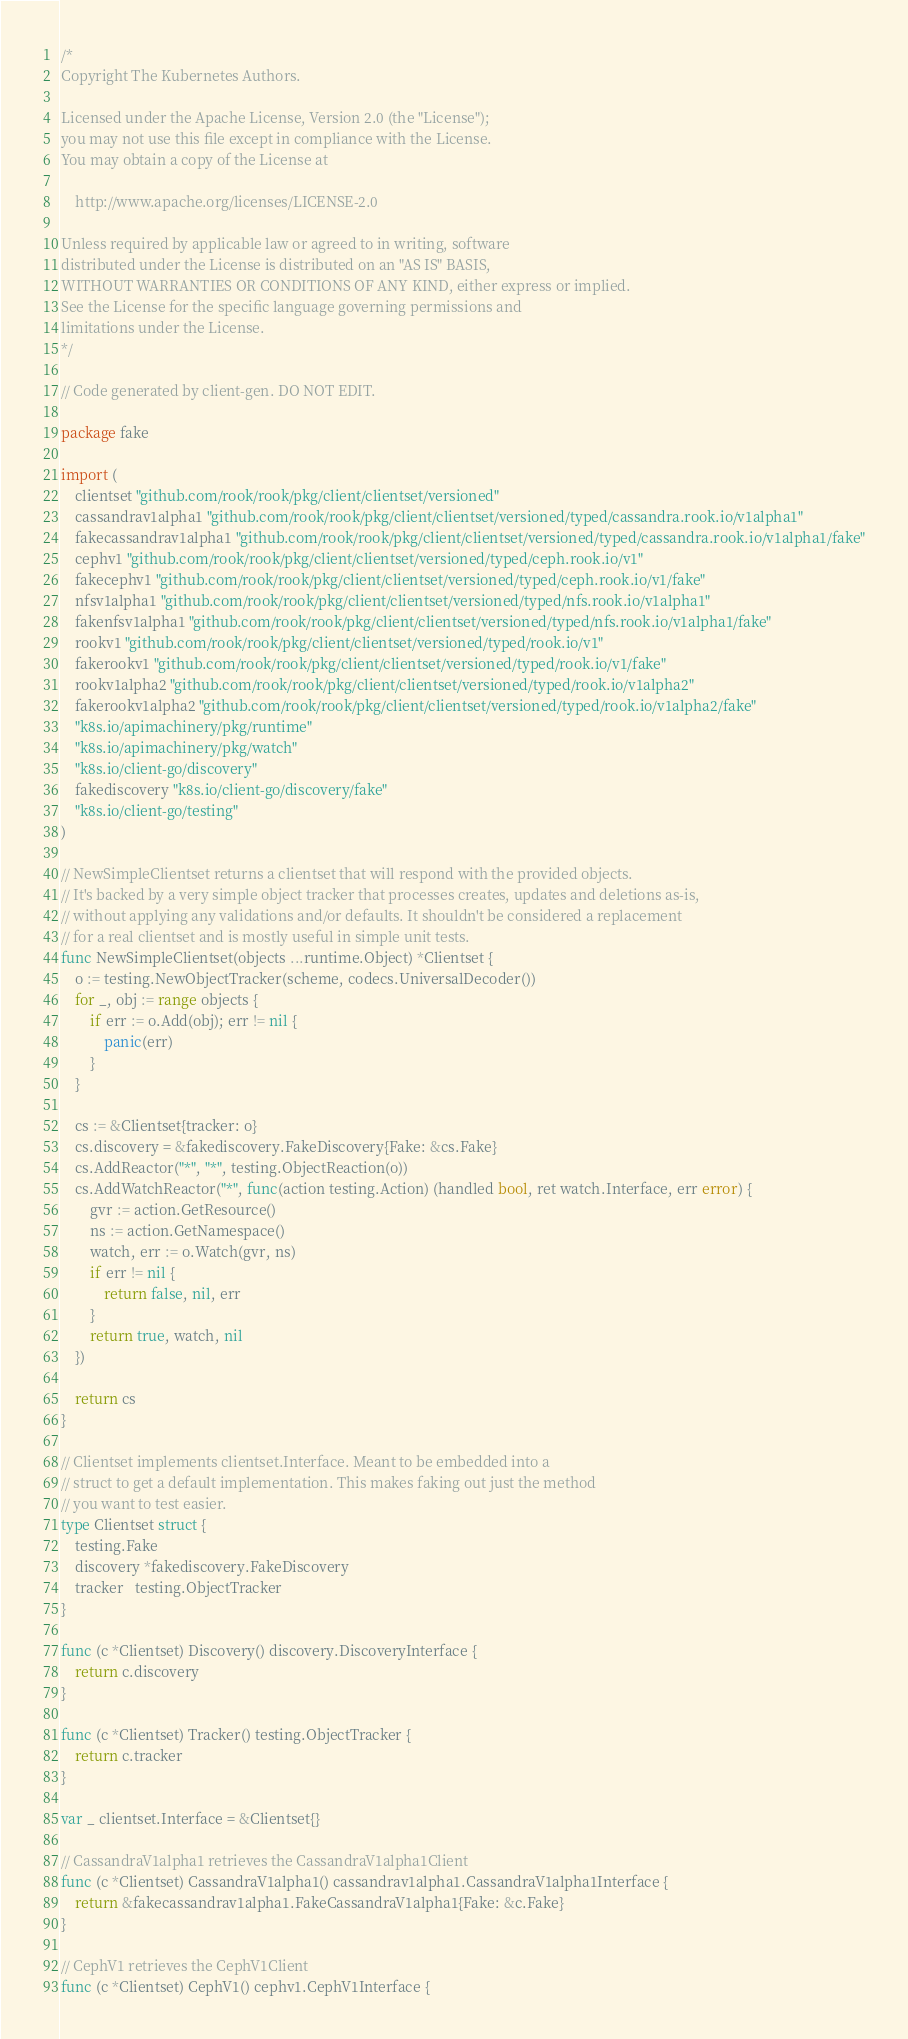Convert code to text. <code><loc_0><loc_0><loc_500><loc_500><_Go_>/*
Copyright The Kubernetes Authors.

Licensed under the Apache License, Version 2.0 (the "License");
you may not use this file except in compliance with the License.
You may obtain a copy of the License at

    http://www.apache.org/licenses/LICENSE-2.0

Unless required by applicable law or agreed to in writing, software
distributed under the License is distributed on an "AS IS" BASIS,
WITHOUT WARRANTIES OR CONDITIONS OF ANY KIND, either express or implied.
See the License for the specific language governing permissions and
limitations under the License.
*/

// Code generated by client-gen. DO NOT EDIT.

package fake

import (
	clientset "github.com/rook/rook/pkg/client/clientset/versioned"
	cassandrav1alpha1 "github.com/rook/rook/pkg/client/clientset/versioned/typed/cassandra.rook.io/v1alpha1"
	fakecassandrav1alpha1 "github.com/rook/rook/pkg/client/clientset/versioned/typed/cassandra.rook.io/v1alpha1/fake"
	cephv1 "github.com/rook/rook/pkg/client/clientset/versioned/typed/ceph.rook.io/v1"
	fakecephv1 "github.com/rook/rook/pkg/client/clientset/versioned/typed/ceph.rook.io/v1/fake"
	nfsv1alpha1 "github.com/rook/rook/pkg/client/clientset/versioned/typed/nfs.rook.io/v1alpha1"
	fakenfsv1alpha1 "github.com/rook/rook/pkg/client/clientset/versioned/typed/nfs.rook.io/v1alpha1/fake"
	rookv1 "github.com/rook/rook/pkg/client/clientset/versioned/typed/rook.io/v1"
	fakerookv1 "github.com/rook/rook/pkg/client/clientset/versioned/typed/rook.io/v1/fake"
	rookv1alpha2 "github.com/rook/rook/pkg/client/clientset/versioned/typed/rook.io/v1alpha2"
	fakerookv1alpha2 "github.com/rook/rook/pkg/client/clientset/versioned/typed/rook.io/v1alpha2/fake"
	"k8s.io/apimachinery/pkg/runtime"
	"k8s.io/apimachinery/pkg/watch"
	"k8s.io/client-go/discovery"
	fakediscovery "k8s.io/client-go/discovery/fake"
	"k8s.io/client-go/testing"
)

// NewSimpleClientset returns a clientset that will respond with the provided objects.
// It's backed by a very simple object tracker that processes creates, updates and deletions as-is,
// without applying any validations and/or defaults. It shouldn't be considered a replacement
// for a real clientset and is mostly useful in simple unit tests.
func NewSimpleClientset(objects ...runtime.Object) *Clientset {
	o := testing.NewObjectTracker(scheme, codecs.UniversalDecoder())
	for _, obj := range objects {
		if err := o.Add(obj); err != nil {
			panic(err)
		}
	}

	cs := &Clientset{tracker: o}
	cs.discovery = &fakediscovery.FakeDiscovery{Fake: &cs.Fake}
	cs.AddReactor("*", "*", testing.ObjectReaction(o))
	cs.AddWatchReactor("*", func(action testing.Action) (handled bool, ret watch.Interface, err error) {
		gvr := action.GetResource()
		ns := action.GetNamespace()
		watch, err := o.Watch(gvr, ns)
		if err != nil {
			return false, nil, err
		}
		return true, watch, nil
	})

	return cs
}

// Clientset implements clientset.Interface. Meant to be embedded into a
// struct to get a default implementation. This makes faking out just the method
// you want to test easier.
type Clientset struct {
	testing.Fake
	discovery *fakediscovery.FakeDiscovery
	tracker   testing.ObjectTracker
}

func (c *Clientset) Discovery() discovery.DiscoveryInterface {
	return c.discovery
}

func (c *Clientset) Tracker() testing.ObjectTracker {
	return c.tracker
}

var _ clientset.Interface = &Clientset{}

// CassandraV1alpha1 retrieves the CassandraV1alpha1Client
func (c *Clientset) CassandraV1alpha1() cassandrav1alpha1.CassandraV1alpha1Interface {
	return &fakecassandrav1alpha1.FakeCassandraV1alpha1{Fake: &c.Fake}
}

// CephV1 retrieves the CephV1Client
func (c *Clientset) CephV1() cephv1.CephV1Interface {</code> 